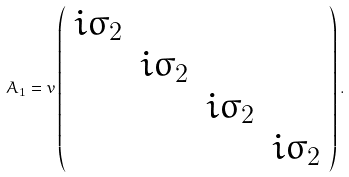<formula> <loc_0><loc_0><loc_500><loc_500>A _ { 1 } = v \left ( \begin{array} { c c c c } i \sigma _ { 2 } & & & \\ & i \sigma _ { 2 } & & \\ & & i \sigma _ { 2 } & \\ & & & i \sigma _ { 2 } \end{array} \right ) .</formula> 